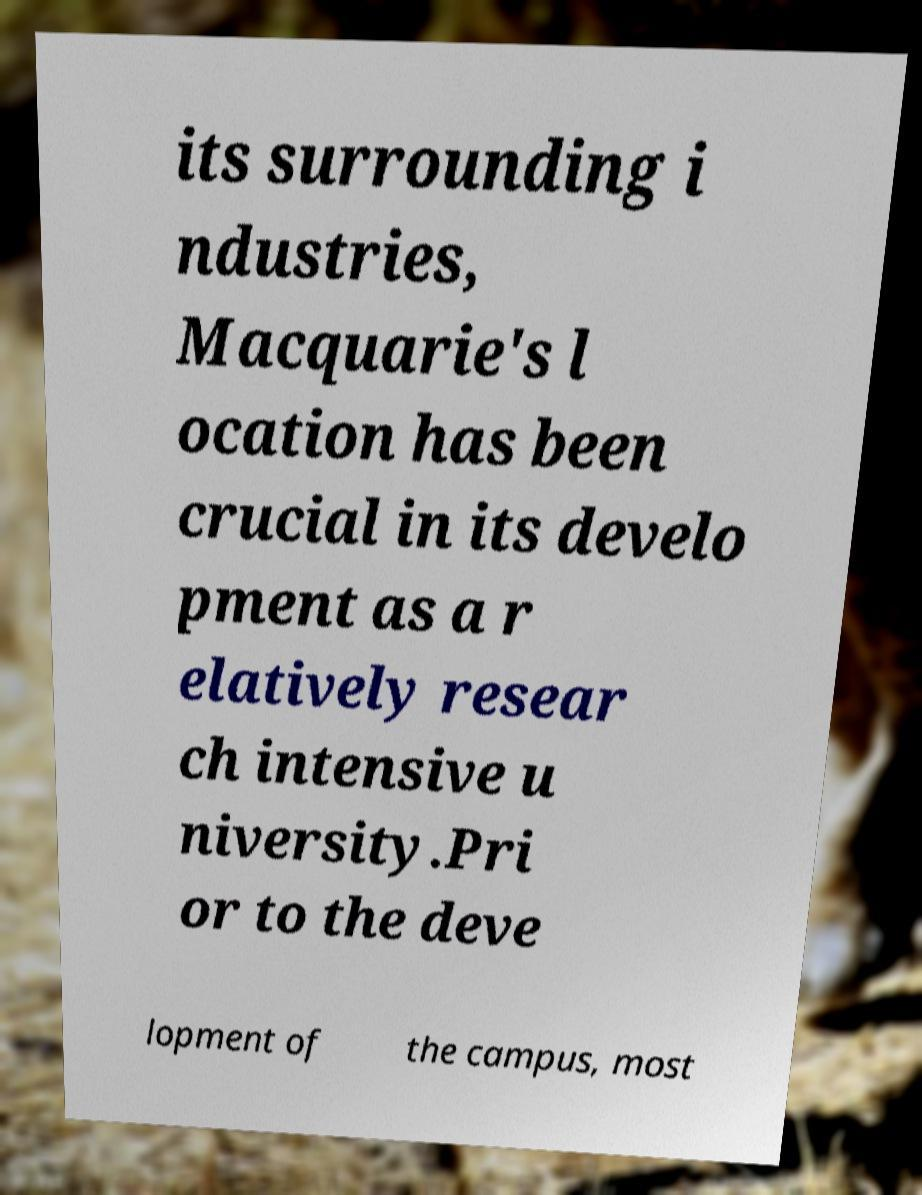Can you read and provide the text displayed in the image?This photo seems to have some interesting text. Can you extract and type it out for me? its surrounding i ndustries, Macquarie's l ocation has been crucial in its develo pment as a r elatively resear ch intensive u niversity.Pri or to the deve lopment of the campus, most 